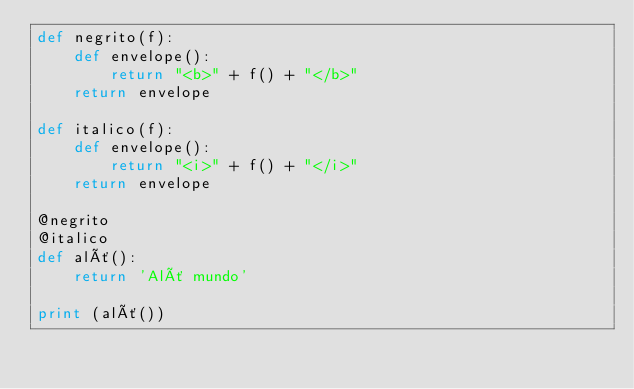<code> <loc_0><loc_0><loc_500><loc_500><_Python_>def negrito(f):
    def envelope():
        return "<b>" + f() + "</b>"
    return envelope

def italico(f):
    def envelope():
        return "<i>" + f() + "</i>"
    return envelope

@negrito
@italico
def alô():
    return 'Alô mundo'

print (alô())
</code> 